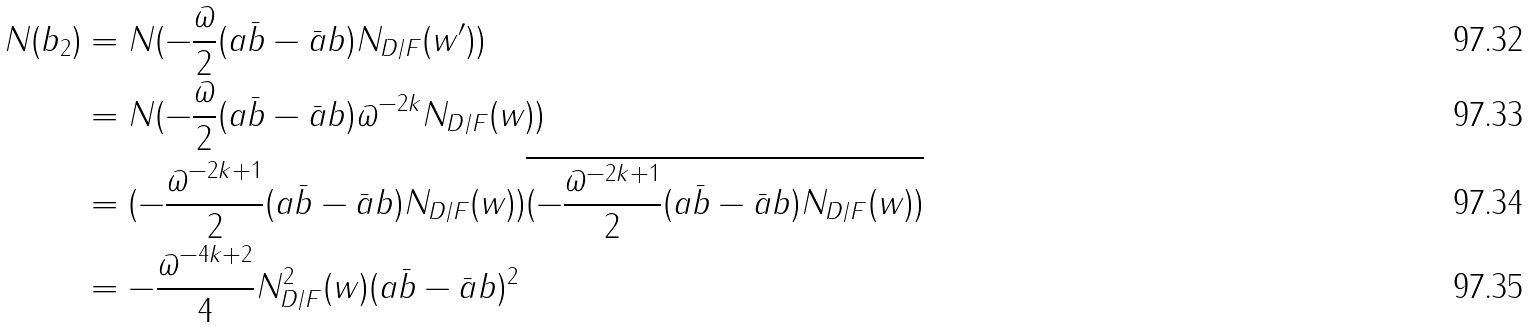Convert formula to latex. <formula><loc_0><loc_0><loc_500><loc_500>N ( b _ { 2 } ) & = N ( - \frac { \varpi } { 2 } ( a \bar { b } - \bar { a } b ) N _ { D / F } ( w ^ { \prime } ) ) \\ & = N ( - \frac { \varpi } { 2 } ( a \bar { b } - \bar { a } b ) \varpi ^ { - 2 k } N _ { D / F } ( w ) ) \\ & = ( - \frac { \varpi ^ { - 2 k + 1 } } { 2 } ( a \bar { b } - \bar { a } b ) N _ { D / F } ( w ) ) \overline { ( - \frac { \varpi ^ { - 2 k + 1 } } { 2 } ( a \bar { b } - \bar { a } b ) N _ { D / F } ( w ) ) } \\ & = - \frac { \varpi ^ { - 4 k + 2 } } { 4 } N _ { D / F } ^ { 2 } ( w ) ( a \bar { b } - \bar { a } b ) ^ { 2 }</formula> 